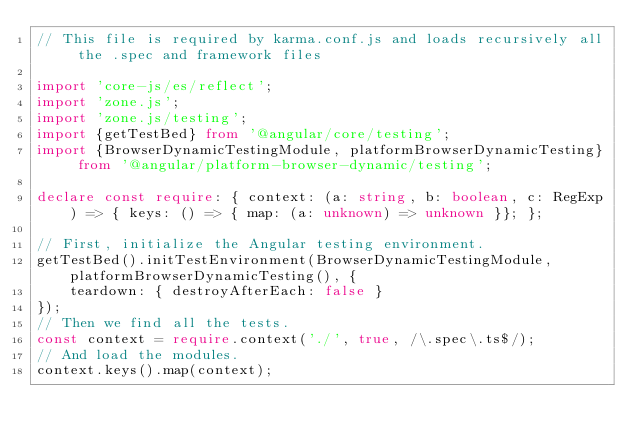<code> <loc_0><loc_0><loc_500><loc_500><_TypeScript_>// This file is required by karma.conf.js and loads recursively all the .spec and framework files

import 'core-js/es/reflect';
import 'zone.js';
import 'zone.js/testing';
import {getTestBed} from '@angular/core/testing';
import {BrowserDynamicTestingModule, platformBrowserDynamicTesting} from '@angular/platform-browser-dynamic/testing';

declare const require: { context: (a: string, b: boolean, c: RegExp) => { keys: () => { map: (a: unknown) => unknown }}; };

// First, initialize the Angular testing environment.
getTestBed().initTestEnvironment(BrowserDynamicTestingModule, platformBrowserDynamicTesting(), {
    teardown: { destroyAfterEach: false }
});
// Then we find all the tests.
const context = require.context('./', true, /\.spec\.ts$/);
// And load the modules.
context.keys().map(context);
</code> 